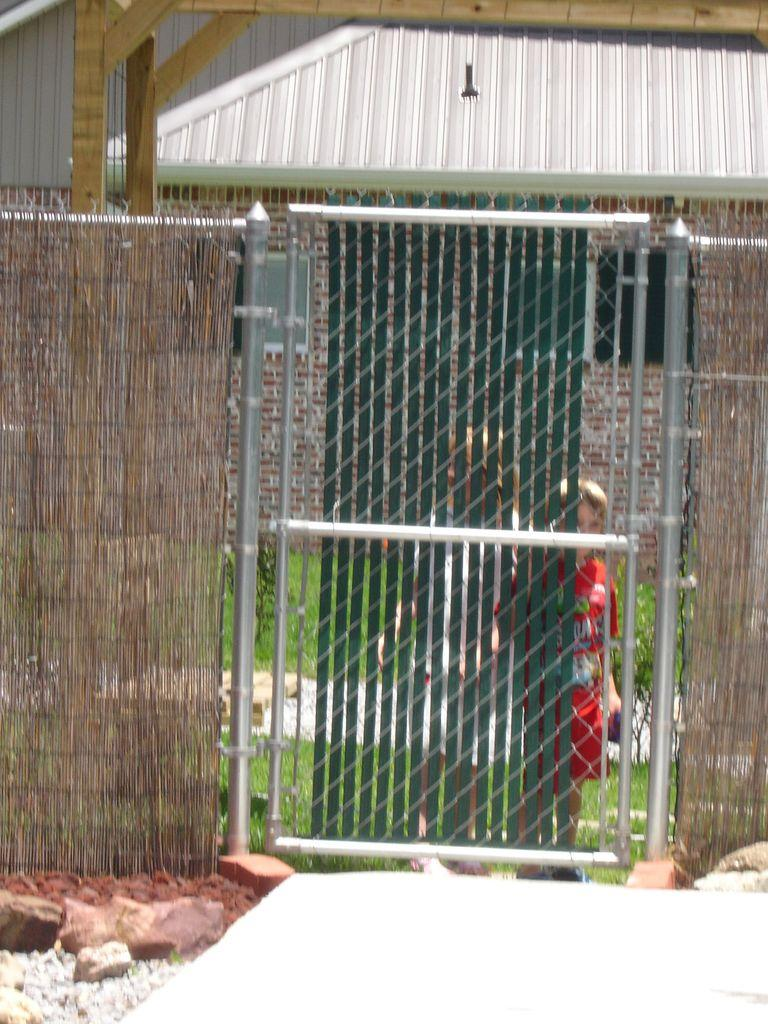What is the main object in the image? There is a closed gate in the image. Who or what is present near the gate? There are two kids standing in the image. What type of terrain is visible in the image? There are rocks visible in the image. What type of structure is located near the gate? A: There is a house with a roof in the image. What architectural elements support the structure in the image? There are wooden pillars in the image. What type of shirt is the doll wearing in the image? There is no doll present in the image, so it is not possible to determine what type of shirt it might be wearing. 